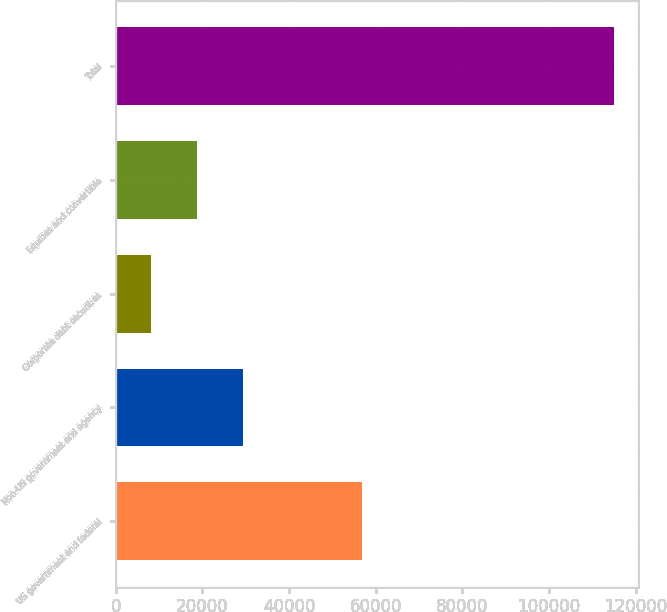<chart> <loc_0><loc_0><loc_500><loc_500><bar_chart><fcel>US government and federal<fcel>Non-US government and agency<fcel>Corporate debt securities<fcel>Equities and convertible<fcel>Total<nl><fcel>56788<fcel>29398.2<fcel>8028<fcel>18713.1<fcel>114879<nl></chart> 